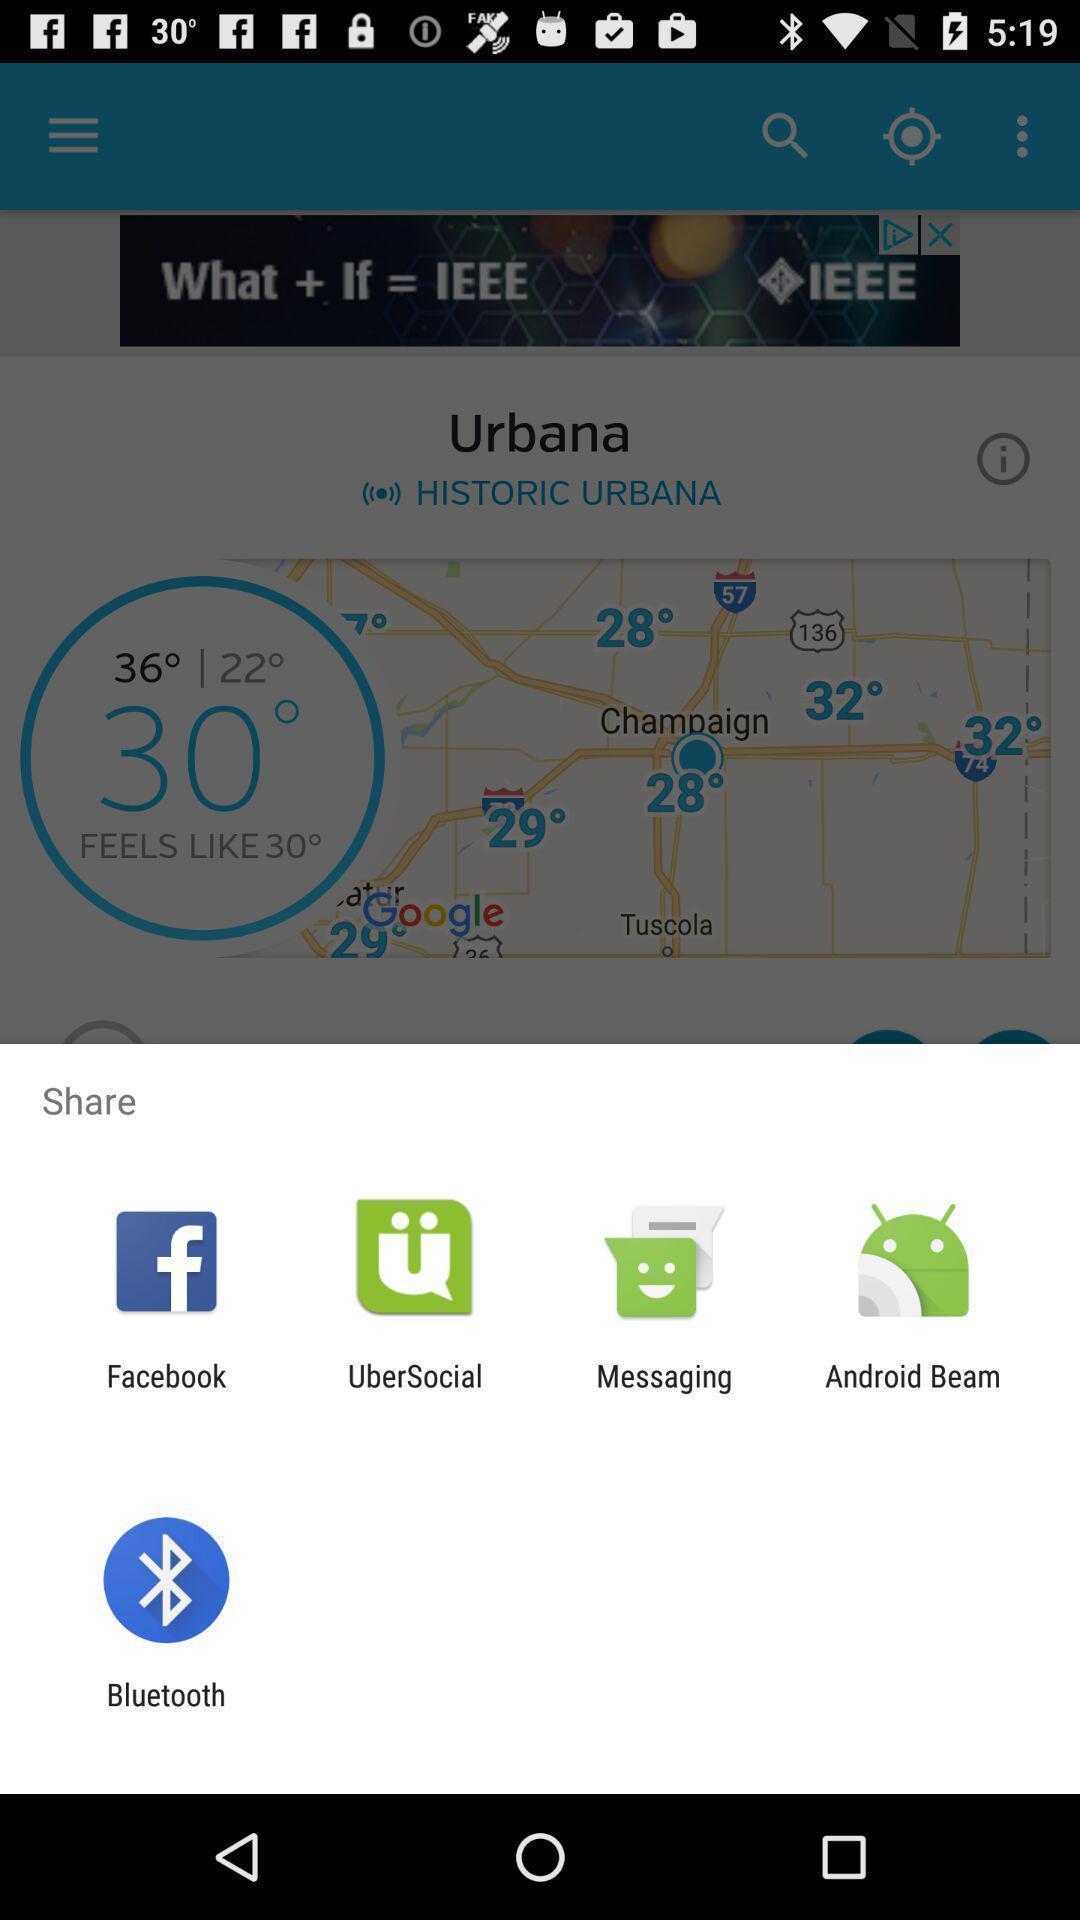Summarize the information in this screenshot. Share location with different apps. 